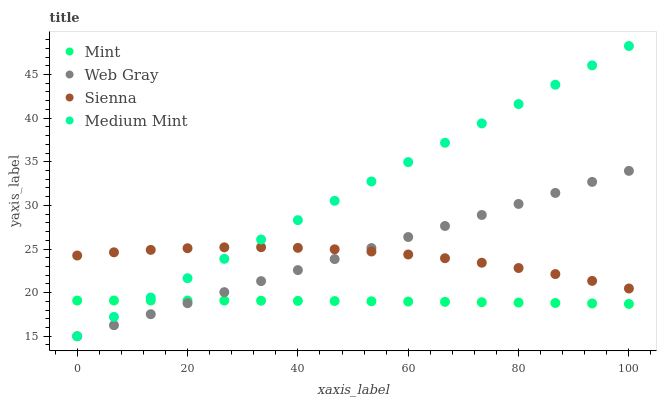Does Mint have the minimum area under the curve?
Answer yes or no. Yes. Does Medium Mint have the maximum area under the curve?
Answer yes or no. Yes. Does Web Gray have the minimum area under the curve?
Answer yes or no. No. Does Web Gray have the maximum area under the curve?
Answer yes or no. No. Is Web Gray the smoothest?
Answer yes or no. Yes. Is Sienna the roughest?
Answer yes or no. Yes. Is Medium Mint the smoothest?
Answer yes or no. No. Is Medium Mint the roughest?
Answer yes or no. No. Does Medium Mint have the lowest value?
Answer yes or no. Yes. Does Mint have the lowest value?
Answer yes or no. No. Does Medium Mint have the highest value?
Answer yes or no. Yes. Does Web Gray have the highest value?
Answer yes or no. No. Is Mint less than Sienna?
Answer yes or no. Yes. Is Sienna greater than Mint?
Answer yes or no. Yes. Does Medium Mint intersect Sienna?
Answer yes or no. Yes. Is Medium Mint less than Sienna?
Answer yes or no. No. Is Medium Mint greater than Sienna?
Answer yes or no. No. Does Mint intersect Sienna?
Answer yes or no. No. 